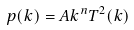<formula> <loc_0><loc_0><loc_500><loc_500>p ( k ) = A k ^ { n } T ^ { 2 } ( k )</formula> 